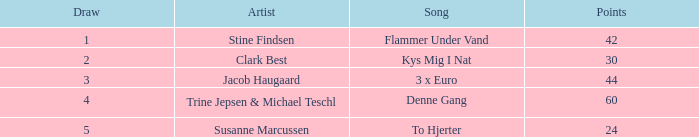What is the minimum draw when the artist is stine findsen and the points exceed 42? None. 